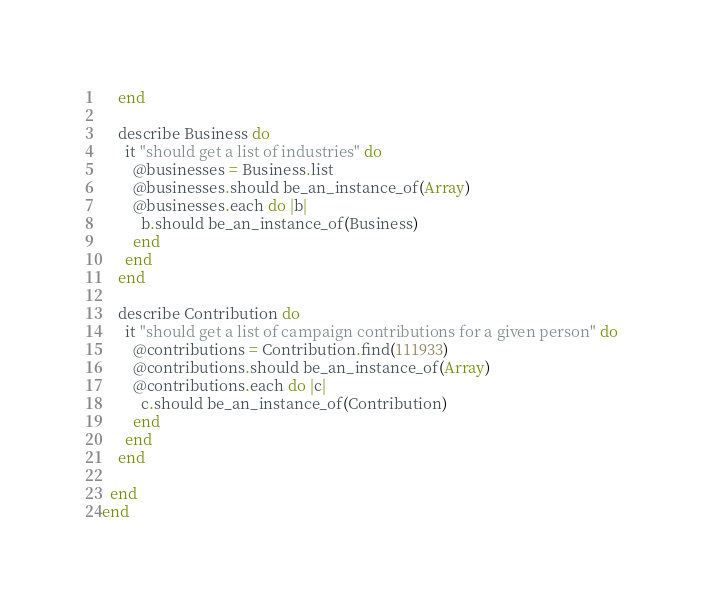Convert code to text. <code><loc_0><loc_0><loc_500><loc_500><_Ruby_>    end

    describe Business do
      it "should get a list of industries" do
        @businesses = Business.list
        @businesses.should be_an_instance_of(Array)
        @businesses.each do |b|
          b.should be_an_instance_of(Business)
        end
      end
    end

    describe Contribution do
      it "should get a list of campaign contributions for a given person" do
        @contributions = Contribution.find(111933)
        @contributions.should be_an_instance_of(Array)
        @contributions.each do |c|
          c.should be_an_instance_of(Contribution)
        end
      end
    end

  end
end</code> 